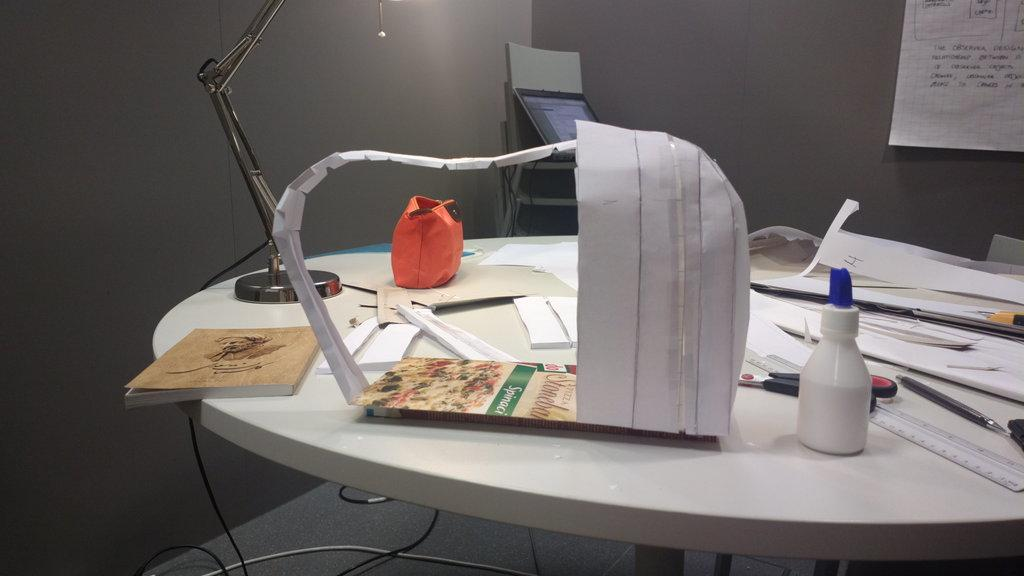What items can be seen in the image related to writing or creating? In the image, there are papers, pens, and scissors, which can be used for writing or creating. What type of container is present in the image? There is a bottle in the image. What is the result of using the items in the image? There is paper art in the image, which suggests that the items were used to create something artistic. What else can be seen in the image related to reading or learning? There is a book in the image, which can be used for reading or learning. What other objects are present in the image that might be related to the creation process? There are wires in the image, which could be used for connecting or powering electronic devices. What can be seen in the background of the image? There is a paper on the wall in the background of the image. How many patches are visible on the leg of the person in the image? There is no person visible in the image, so it is not possible to determine the number of patches on their leg. 